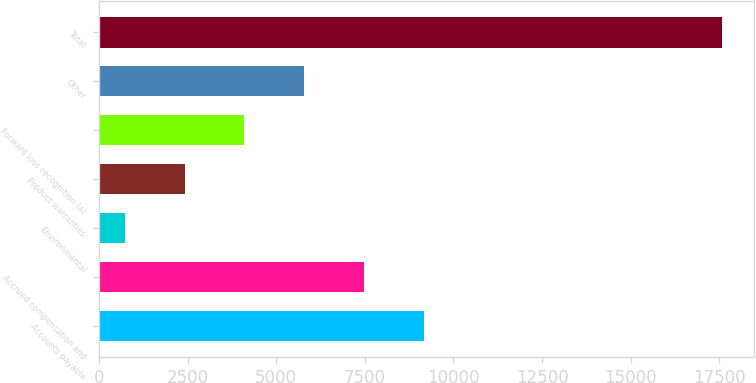Convert chart to OTSL. <chart><loc_0><loc_0><loc_500><loc_500><bar_chart><fcel>Accounts payable<fcel>Accrued compensation and<fcel>Environmental<fcel>Product warranties<fcel>Forward loss recognition (a)<fcel>Other<fcel>Total<nl><fcel>9159<fcel>7473.4<fcel>731<fcel>2416.6<fcel>4102.2<fcel>5787.8<fcel>17587<nl></chart> 